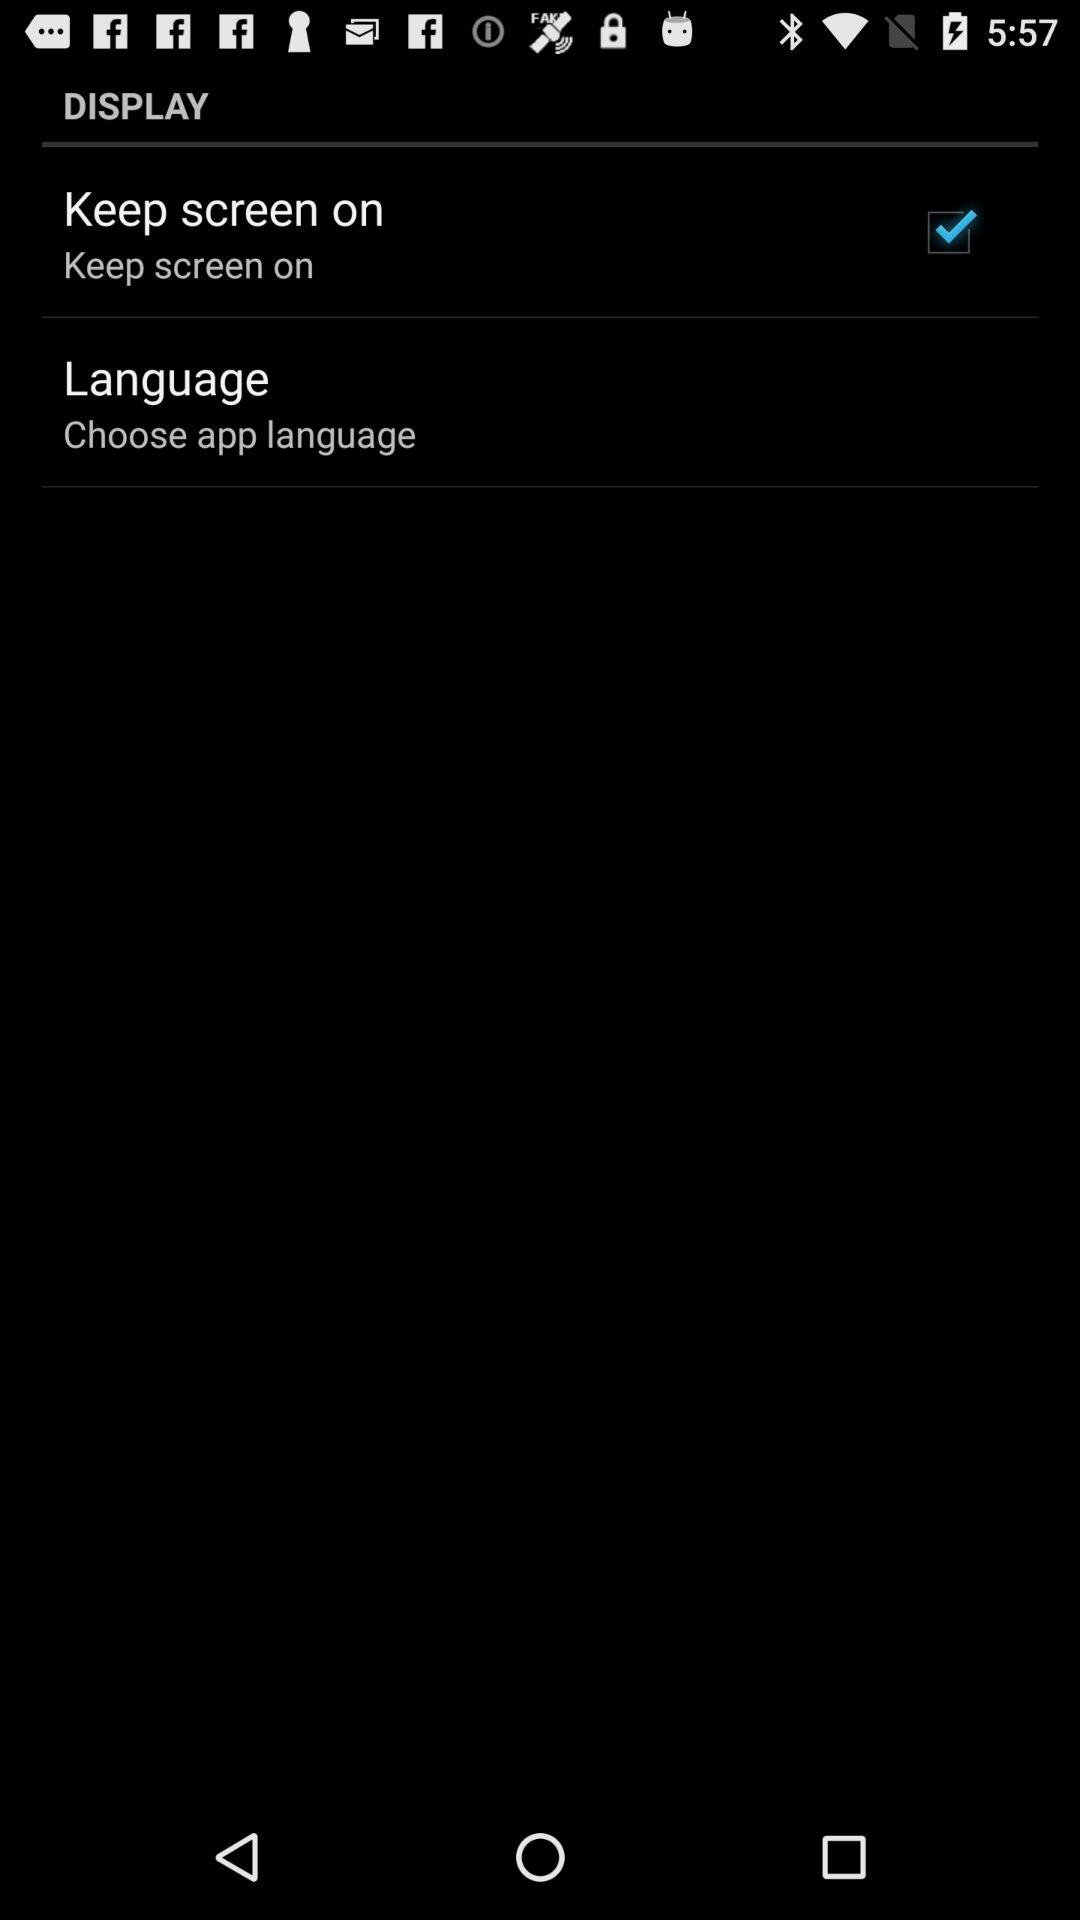What is the status of the "Keep screen on"? The status is "on". 